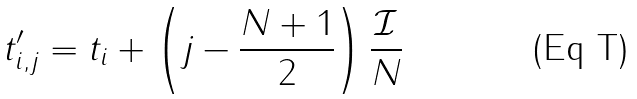Convert formula to latex. <formula><loc_0><loc_0><loc_500><loc_500>t _ { i , j } ^ { \prime } = t _ { i } + \left ( j - \frac { N + 1 } { 2 } \right ) \frac { \mathcal { I } } { N }</formula> 